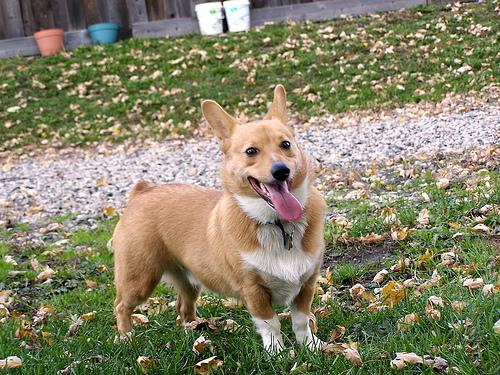If the dog in the image were to star in a movie, what genre do you think would be fitting and why? Given the Pembroke Welsh Corgi's lively demeanor and expressive countenance, it would be perfectly cast in a comedy or family film. The breed is known for its mischievous yet loving personality, which would lend itself well to a narrative filled with lighthearted antics and heartwarming moments. Picture our canine hero embarking on a suburban adventure, perhaps helping to reunite a family or outsmarting a comically inept antagonist—all the while demonstrating the breed's cleverness and charm. With a Corgi's innate ability to elicit smiles and laughter, audiences would undoubtedly be captivated by the dog's on-screen escapades. 